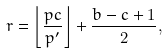<formula> <loc_0><loc_0><loc_500><loc_500>r = \left \lfloor \frac { p c } { p ^ { \prime } } \right \rfloor + \frac { b - c + 1 } 2 ,</formula> 